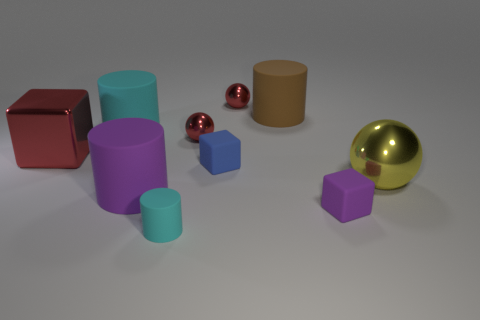What number of objects are either tiny metallic things behind the big cyan matte cylinder or tiny things to the right of the small cylinder?
Provide a succinct answer. 4. Does the brown cylinder have the same size as the blue object?
Your answer should be compact. No. Is the number of big shiny objects greater than the number of tiny red cylinders?
Your answer should be very brief. Yes. How many other things are the same color as the metal block?
Give a very brief answer. 2. How many objects are large purple rubber objects or matte objects?
Give a very brief answer. 6. There is a red shiny thing that is behind the large cyan matte thing; is its shape the same as the blue thing?
Your response must be concise. No. What color is the tiny thing behind the cyan matte cylinder that is behind the red metallic cube?
Offer a terse response. Red. Are there fewer small shiny spheres than small purple rubber cylinders?
Offer a very short reply. No. Are there any big brown things that have the same material as the small purple cube?
Keep it short and to the point. Yes. There is a large brown rubber object; is its shape the same as the large rubber thing in front of the large yellow sphere?
Offer a very short reply. Yes. 